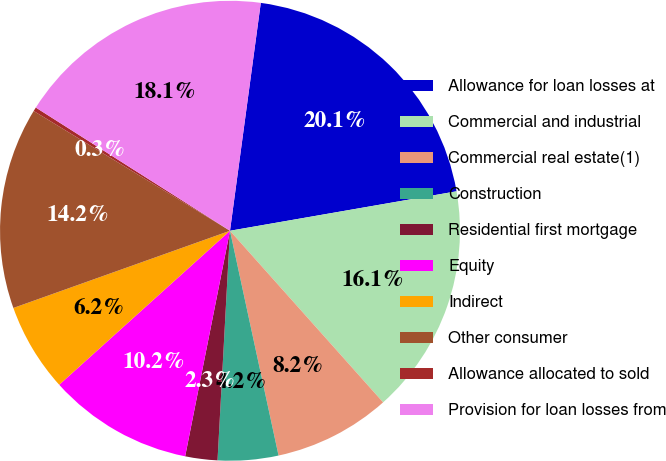Convert chart. <chart><loc_0><loc_0><loc_500><loc_500><pie_chart><fcel>Allowance for loan losses at<fcel>Commercial and industrial<fcel>Commercial real estate(1)<fcel>Construction<fcel>Residential first mortgage<fcel>Equity<fcel>Indirect<fcel>Other consumer<fcel>Allowance allocated to sold<fcel>Provision for loan losses from<nl><fcel>20.12%<fcel>16.15%<fcel>8.21%<fcel>4.25%<fcel>2.26%<fcel>10.2%<fcel>6.23%<fcel>14.17%<fcel>0.28%<fcel>18.14%<nl></chart> 